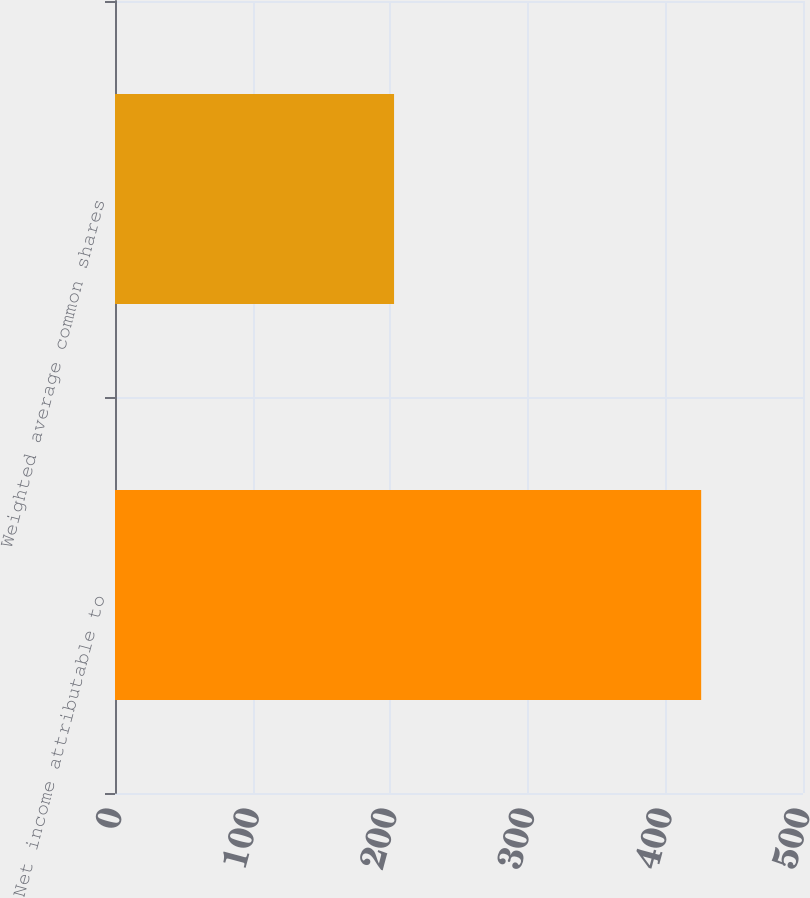Convert chart to OTSL. <chart><loc_0><loc_0><loc_500><loc_500><bar_chart><fcel>Net income attributable to<fcel>Weighted average common shares<nl><fcel>426<fcel>202.8<nl></chart> 